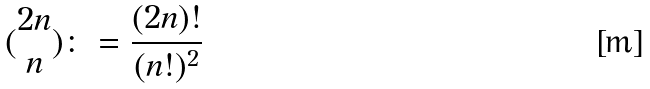<formula> <loc_0><loc_0><loc_500><loc_500>( \begin{matrix} 2 n \\ n \end{matrix} ) \colon = \frac { ( 2 n ) ! } { ( n ! ) ^ { 2 } }</formula> 